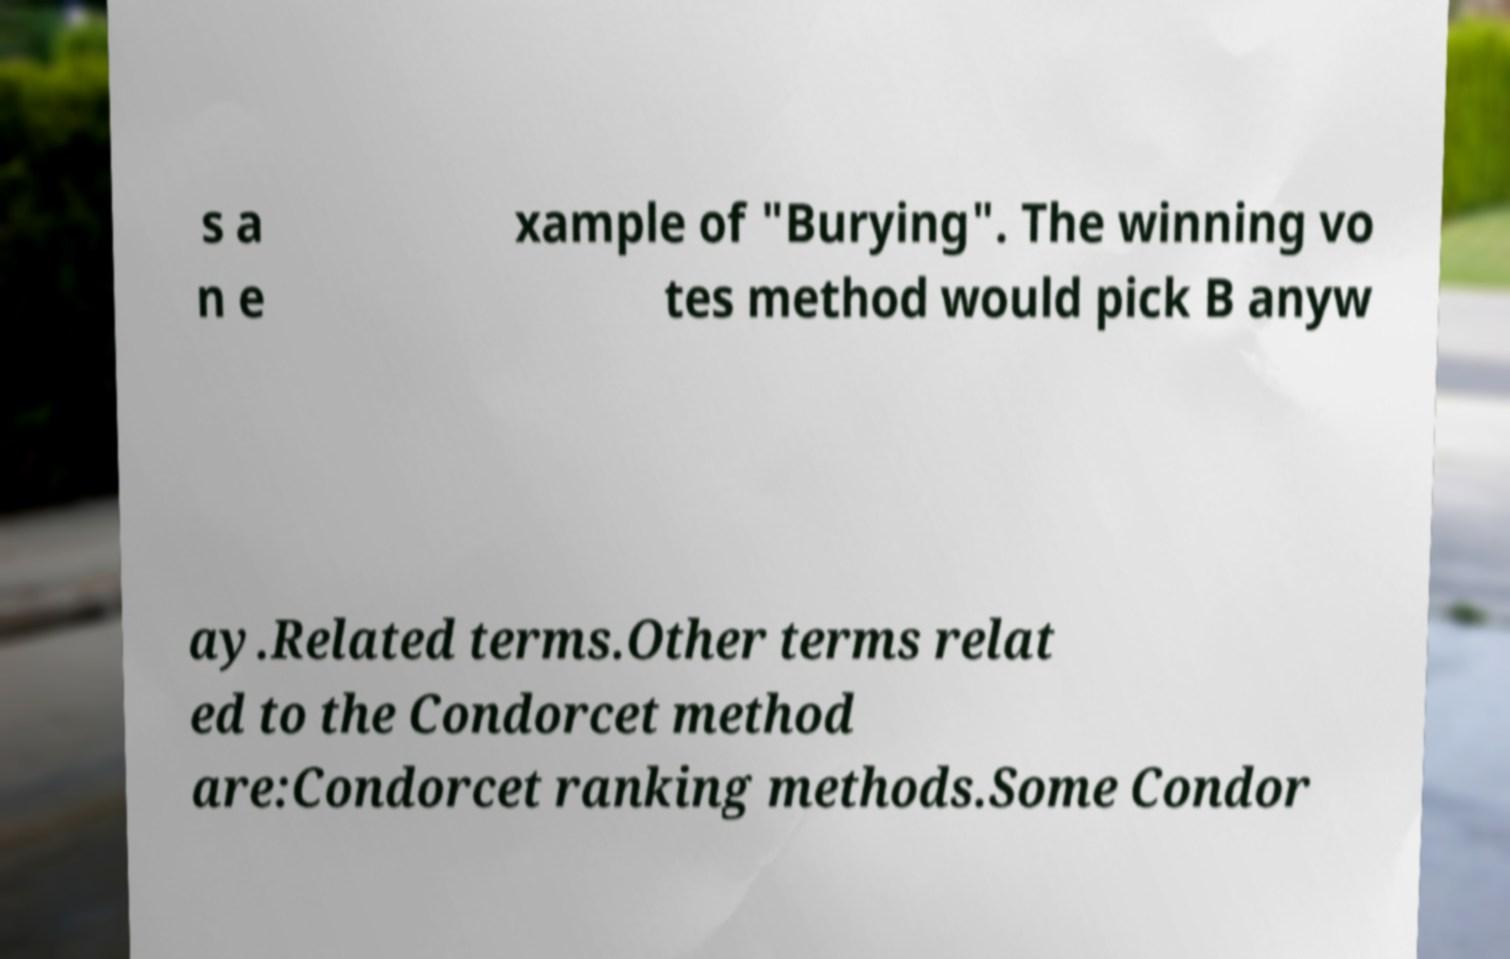Can you read and provide the text displayed in the image?This photo seems to have some interesting text. Can you extract and type it out for me? s a n e xample of "Burying". The winning vo tes method would pick B anyw ay.Related terms.Other terms relat ed to the Condorcet method are:Condorcet ranking methods.Some Condor 